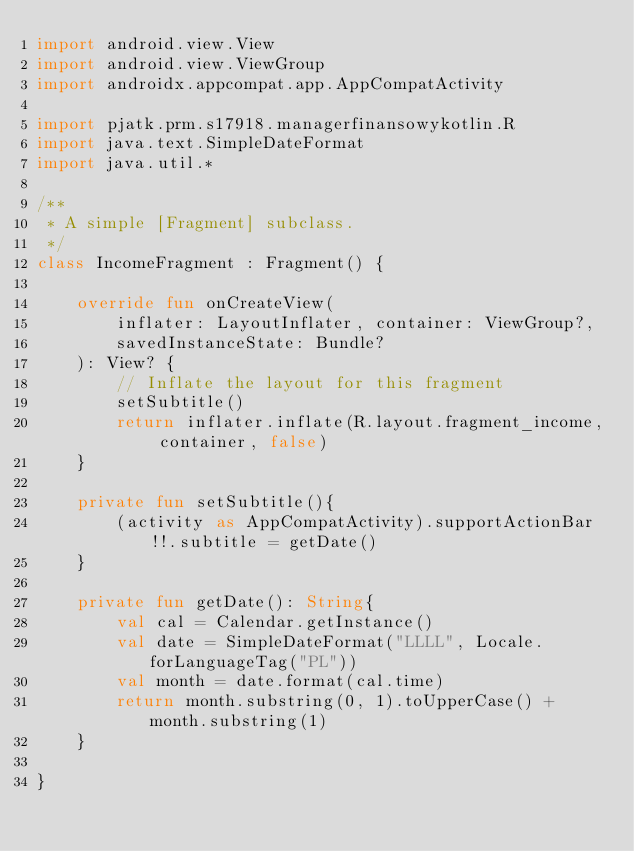<code> <loc_0><loc_0><loc_500><loc_500><_Kotlin_>import android.view.View
import android.view.ViewGroup
import androidx.appcompat.app.AppCompatActivity

import pjatk.prm.s17918.managerfinansowykotlin.R
import java.text.SimpleDateFormat
import java.util.*

/**
 * A simple [Fragment] subclass.
 */
class IncomeFragment : Fragment() {

    override fun onCreateView(
        inflater: LayoutInflater, container: ViewGroup?,
        savedInstanceState: Bundle?
    ): View? {
        // Inflate the layout for this fragment
        setSubtitle()
        return inflater.inflate(R.layout.fragment_income, container, false)
    }

    private fun setSubtitle(){
        (activity as AppCompatActivity).supportActionBar!!.subtitle = getDate()
    }

    private fun getDate(): String{
        val cal = Calendar.getInstance()
        val date = SimpleDateFormat("LLLL", Locale.forLanguageTag("PL"))
        val month = date.format(cal.time)
        return month.substring(0, 1).toUpperCase() + month.substring(1)
    }

}
</code> 